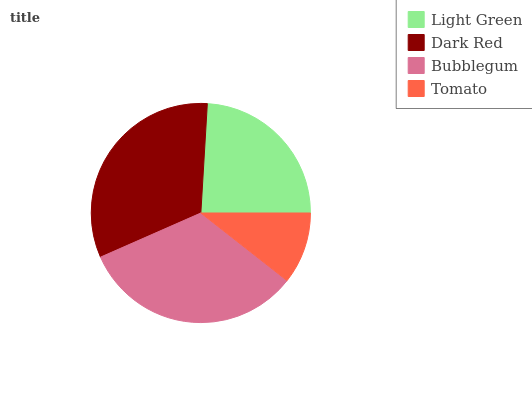Is Tomato the minimum?
Answer yes or no. Yes. Is Bubblegum the maximum?
Answer yes or no. Yes. Is Dark Red the minimum?
Answer yes or no. No. Is Dark Red the maximum?
Answer yes or no. No. Is Dark Red greater than Light Green?
Answer yes or no. Yes. Is Light Green less than Dark Red?
Answer yes or no. Yes. Is Light Green greater than Dark Red?
Answer yes or no. No. Is Dark Red less than Light Green?
Answer yes or no. No. Is Dark Red the high median?
Answer yes or no. Yes. Is Light Green the low median?
Answer yes or no. Yes. Is Bubblegum the high median?
Answer yes or no. No. Is Dark Red the low median?
Answer yes or no. No. 